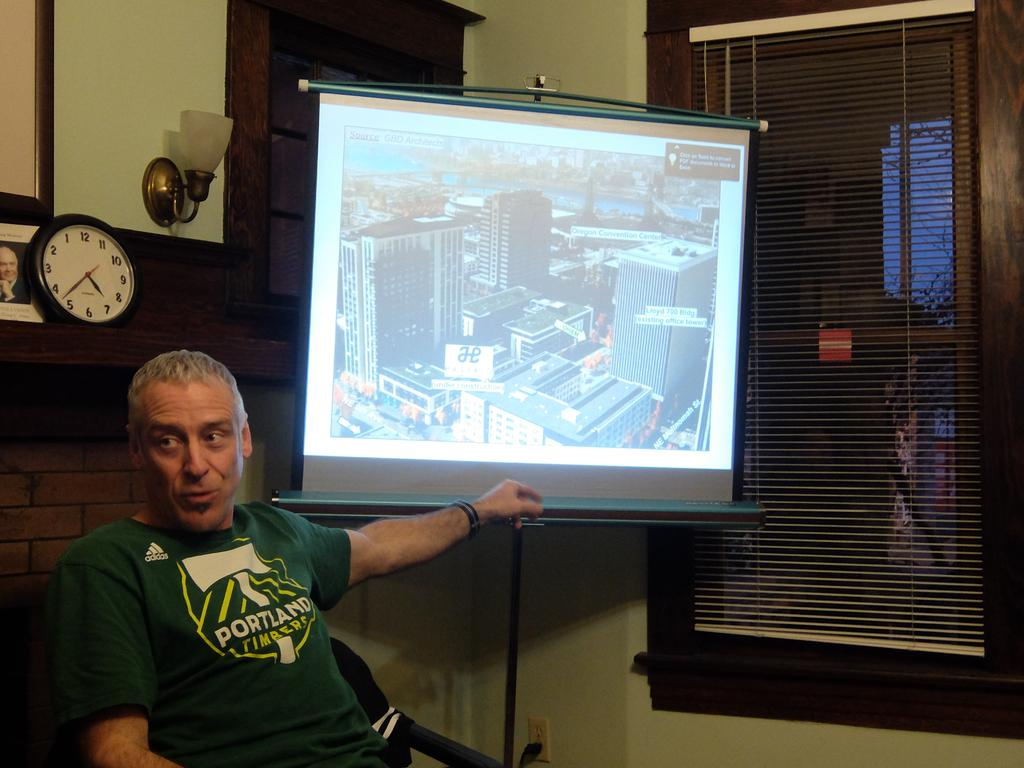<image>
Present a compact description of the photo's key features. A man in a green Portland shirt sits by a presentation screen. 